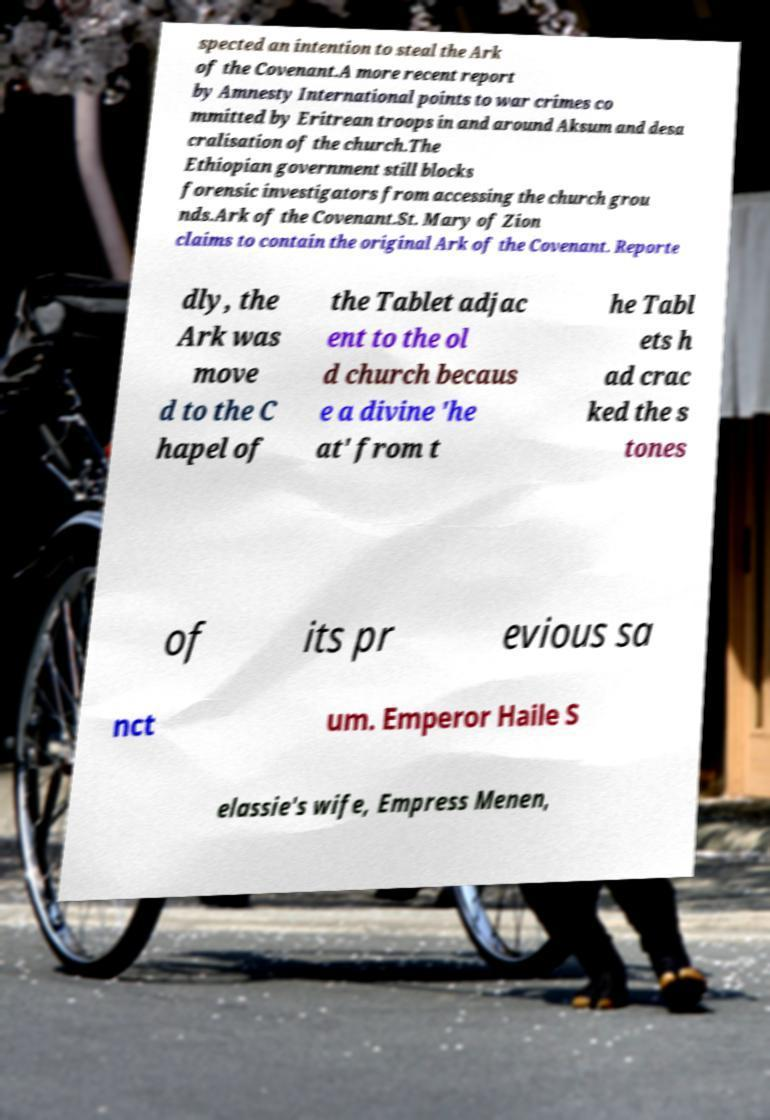For documentation purposes, I need the text within this image transcribed. Could you provide that? spected an intention to steal the Ark of the Covenant.A more recent report by Amnesty International points to war crimes co mmitted by Eritrean troops in and around Aksum and desa cralisation of the church.The Ethiopian government still blocks forensic investigators from accessing the church grou nds.Ark of the Covenant.St. Mary of Zion claims to contain the original Ark of the Covenant. Reporte dly, the Ark was move d to the C hapel of the Tablet adjac ent to the ol d church becaus e a divine 'he at' from t he Tabl ets h ad crac ked the s tones of its pr evious sa nct um. Emperor Haile S elassie's wife, Empress Menen, 